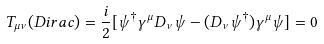Convert formula to latex. <formula><loc_0><loc_0><loc_500><loc_500>T _ { \mu \nu } ( D i r a c ) = \frac { i } { 2 } [ \psi ^ { \dagger } \gamma ^ { \mu } D _ { \nu } \psi - ( D _ { \nu } \psi ^ { \dagger } ) \gamma ^ { \mu } \psi ] = 0</formula> 